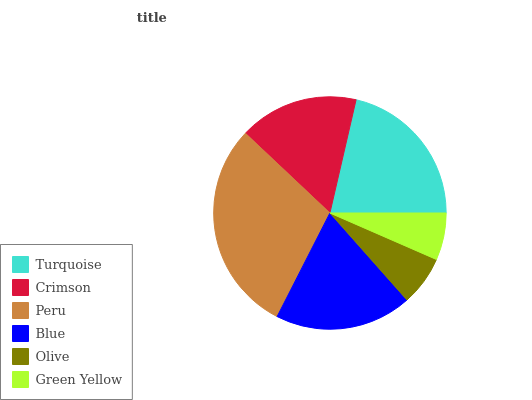Is Green Yellow the minimum?
Answer yes or no. Yes. Is Peru the maximum?
Answer yes or no. Yes. Is Crimson the minimum?
Answer yes or no. No. Is Crimson the maximum?
Answer yes or no. No. Is Turquoise greater than Crimson?
Answer yes or no. Yes. Is Crimson less than Turquoise?
Answer yes or no. Yes. Is Crimson greater than Turquoise?
Answer yes or no. No. Is Turquoise less than Crimson?
Answer yes or no. No. Is Blue the high median?
Answer yes or no. Yes. Is Crimson the low median?
Answer yes or no. Yes. Is Peru the high median?
Answer yes or no. No. Is Peru the low median?
Answer yes or no. No. 